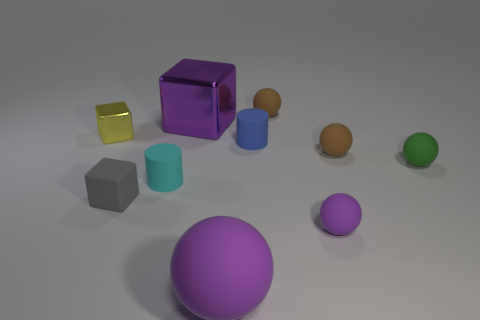Subtract all green spheres. How many spheres are left? 4 Subtract all green spheres. How many spheres are left? 4 Subtract all yellow balls. Subtract all yellow cubes. How many balls are left? 5 Subtract all cylinders. How many objects are left? 8 Add 10 small green shiny things. How many small green shiny things exist? 10 Subtract 1 purple blocks. How many objects are left? 9 Subtract all large gray matte things. Subtract all small cyan objects. How many objects are left? 9 Add 3 metallic things. How many metallic things are left? 5 